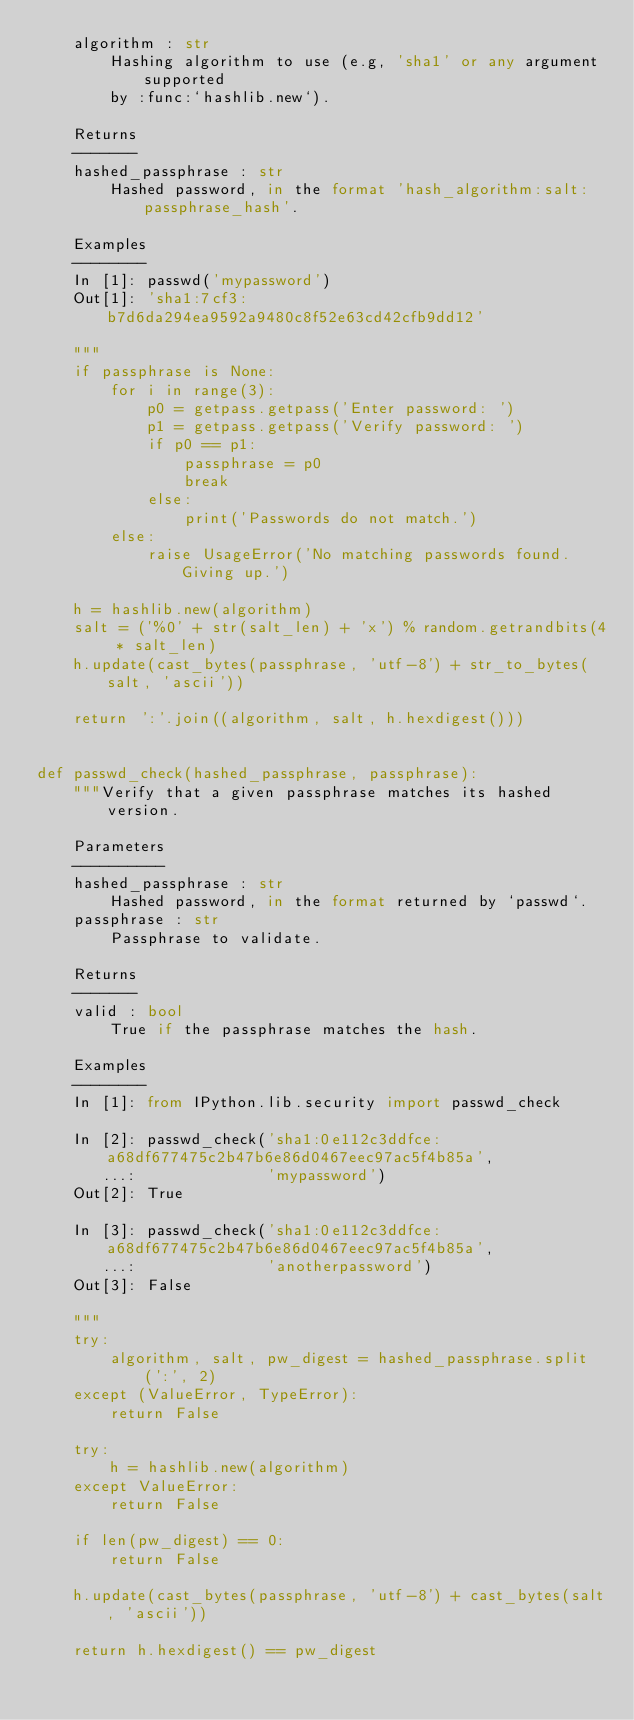<code> <loc_0><loc_0><loc_500><loc_500><_Python_>    algorithm : str
        Hashing algorithm to use (e.g, 'sha1' or any argument supported
        by :func:`hashlib.new`).

    Returns
    -------
    hashed_passphrase : str
        Hashed password, in the format 'hash_algorithm:salt:passphrase_hash'.

    Examples
    --------
    In [1]: passwd('mypassword')
    Out[1]: 'sha1:7cf3:b7d6da294ea9592a9480c8f52e63cd42cfb9dd12'

    """
    if passphrase is None:
        for i in range(3):
            p0 = getpass.getpass('Enter password: ')
            p1 = getpass.getpass('Verify password: ')
            if p0 == p1:
                passphrase = p0
                break
            else:
                print('Passwords do not match.')
        else:
            raise UsageError('No matching passwords found. Giving up.')

    h = hashlib.new(algorithm)
    salt = ('%0' + str(salt_len) + 'x') % random.getrandbits(4 * salt_len)
    h.update(cast_bytes(passphrase, 'utf-8') + str_to_bytes(salt, 'ascii'))

    return ':'.join((algorithm, salt, h.hexdigest()))


def passwd_check(hashed_passphrase, passphrase):
    """Verify that a given passphrase matches its hashed version.

    Parameters
    ----------
    hashed_passphrase : str
        Hashed password, in the format returned by `passwd`.
    passphrase : str
        Passphrase to validate.

    Returns
    -------
    valid : bool
        True if the passphrase matches the hash.

    Examples
    --------
    In [1]: from IPython.lib.security import passwd_check

    In [2]: passwd_check('sha1:0e112c3ddfce:a68df677475c2b47b6e86d0467eec97ac5f4b85a',
       ...:              'mypassword')
    Out[2]: True

    In [3]: passwd_check('sha1:0e112c3ddfce:a68df677475c2b47b6e86d0467eec97ac5f4b85a',
       ...:              'anotherpassword')
    Out[3]: False

    """
    try:
        algorithm, salt, pw_digest = hashed_passphrase.split(':', 2)
    except (ValueError, TypeError):
        return False

    try:
        h = hashlib.new(algorithm)
    except ValueError:
        return False

    if len(pw_digest) == 0:
        return False

    h.update(cast_bytes(passphrase, 'utf-8') + cast_bytes(salt, 'ascii'))

    return h.hexdigest() == pw_digest
</code> 